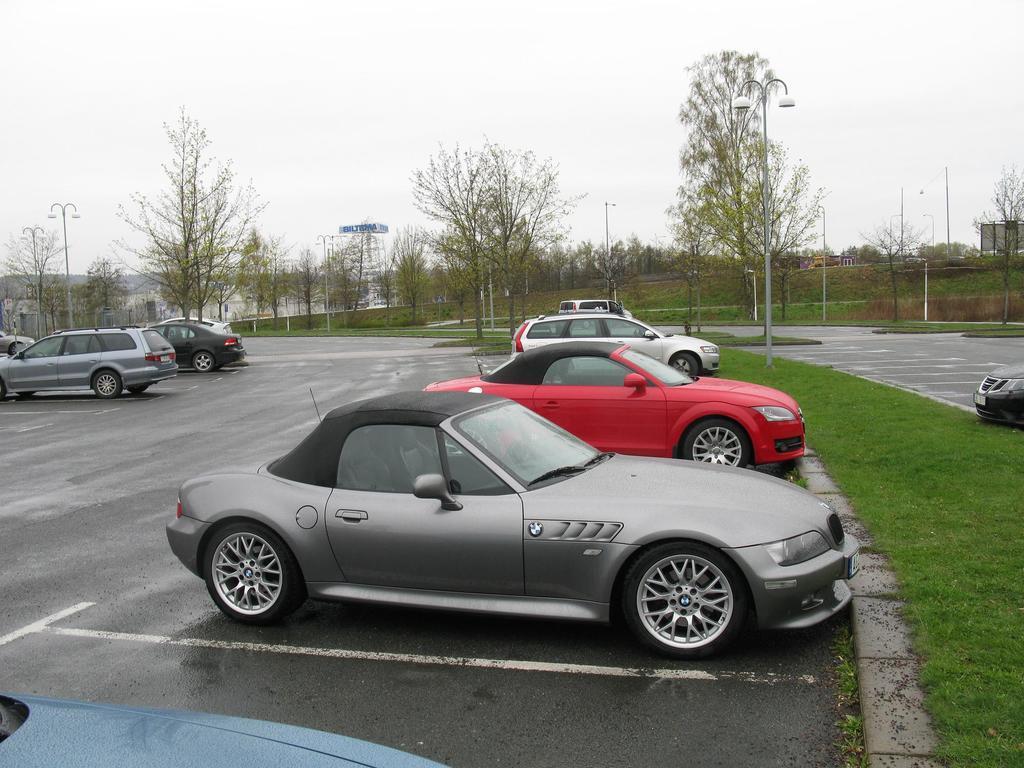Describe this image in one or two sentences. In the image we can see there are many vehicles of different colors and sizes. Here we can see the road, grass, trees, poles and the white sky. 